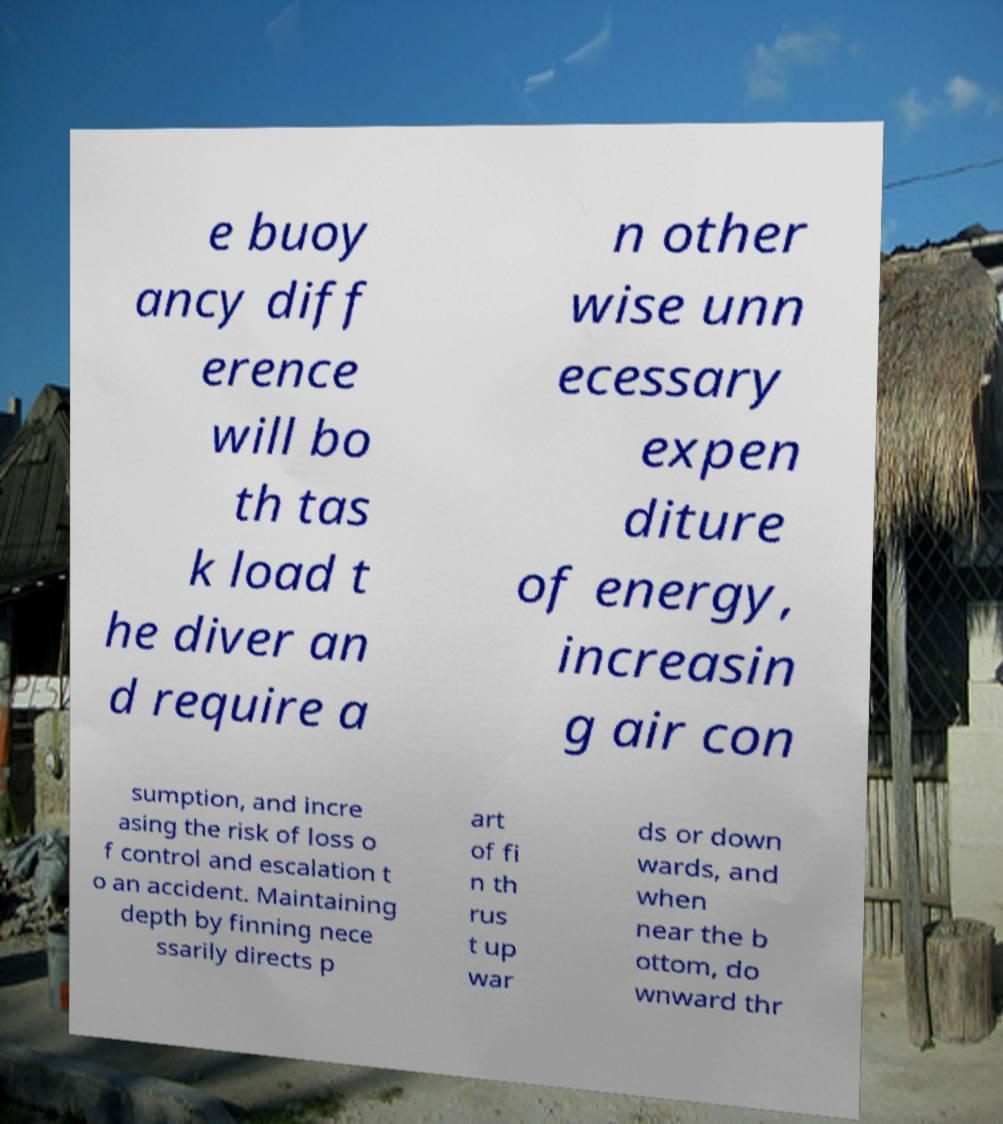There's text embedded in this image that I need extracted. Can you transcribe it verbatim? e buoy ancy diff erence will bo th tas k load t he diver an d require a n other wise unn ecessary expen diture of energy, increasin g air con sumption, and incre asing the risk of loss o f control and escalation t o an accident. Maintaining depth by finning nece ssarily directs p art of fi n th rus t up war ds or down wards, and when near the b ottom, do wnward thr 